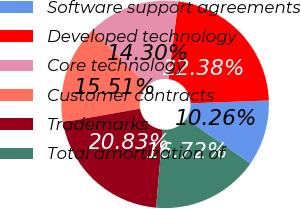Convert chart to OTSL. <chart><loc_0><loc_0><loc_500><loc_500><pie_chart><fcel>Software support agreements<fcel>Developed technology<fcel>Core technology<fcel>Customer contracts<fcel>Trademarks<fcel>Total amortization of<nl><fcel>10.26%<fcel>22.38%<fcel>14.3%<fcel>15.51%<fcel>20.83%<fcel>16.72%<nl></chart> 